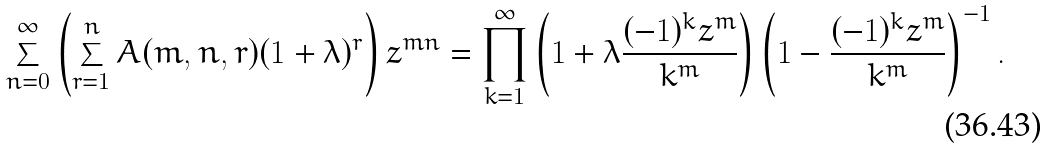<formula> <loc_0><loc_0><loc_500><loc_500>\sum _ { n = 0 } ^ { \infty } \left ( \sum _ { r = 1 } ^ { n } A ( m , n , r ) ( 1 + \lambda ) ^ { r } \right ) z ^ { m n } = \prod _ { k = 1 } ^ { \infty } \left ( 1 + \lambda \frac { ( - 1 ) ^ { k } z ^ { m } } { k ^ { m } } \right ) \left ( 1 - \frac { ( - 1 ) ^ { k } z ^ { m } } { k ^ { m } } \right ) ^ { - 1 } .</formula> 